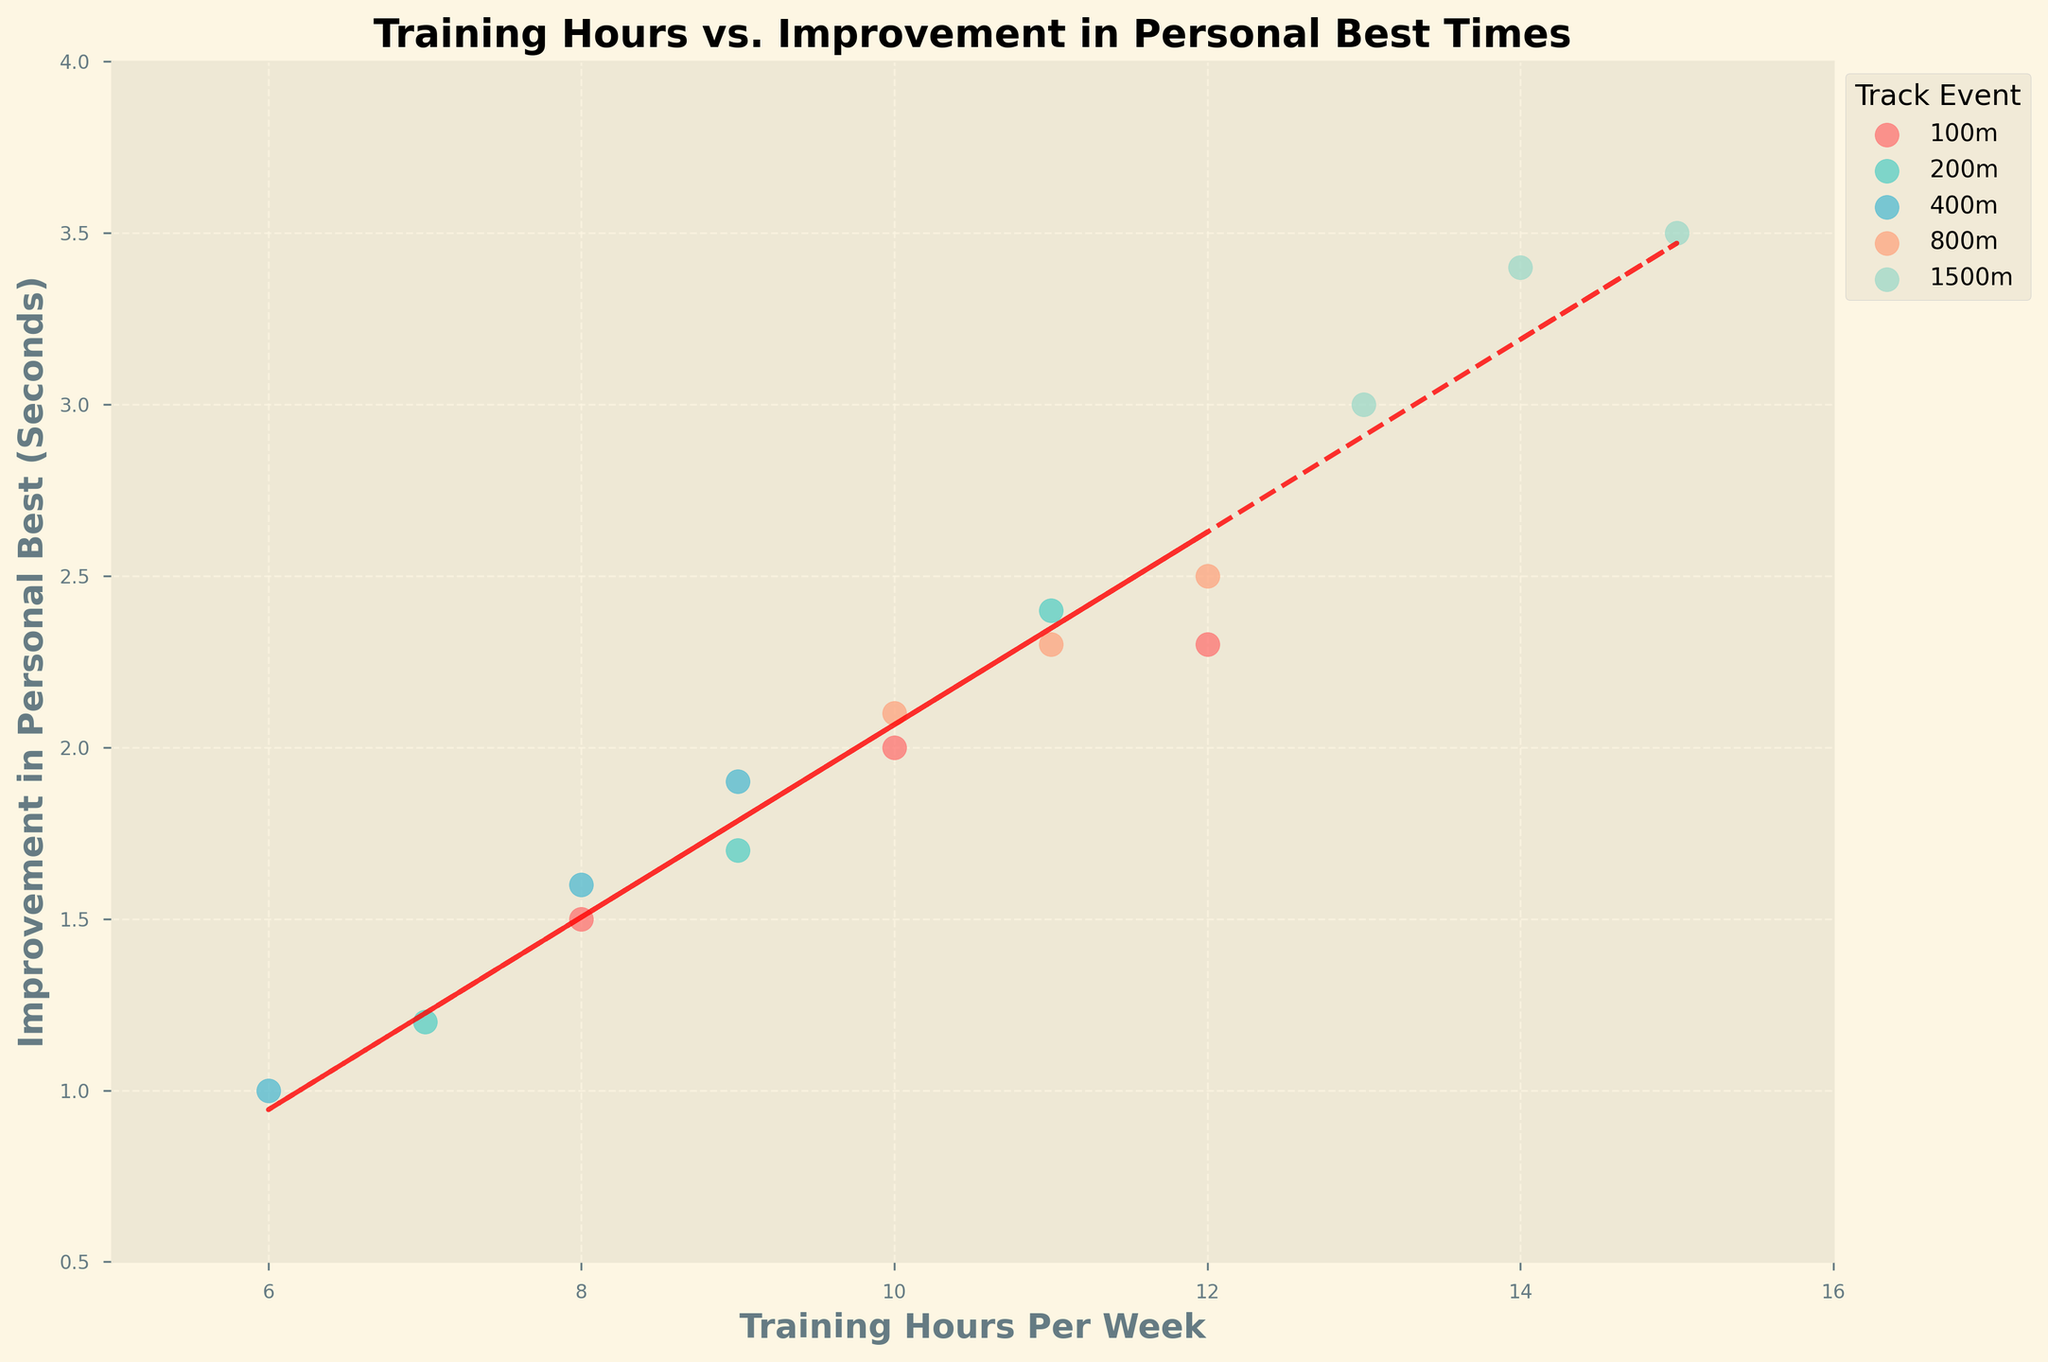What is the title of the plot? The title is usually displayed at the top of the plot and summarizes the subject of the chart. In this case, the title is "Training Hours vs. Improvement in Personal Best Times."
Answer: Training Hours vs. Improvement in Personal Best Times How many unique track events are represented in the plot? To find the number of unique track events, look at the legend and count the different track events specified. The legend shows the colors and the associated track events.
Answer: 5 What is the trend line's general direction? The trend line shows the general relationship between Training Hours Per Week and Improvement in Personal Best Times. It appears to be sloping upwards, indicating that as training hours increase, the improvement in personal best times also tends to increase.
Answer: Upwards Which track event has the color represented by '#4ECDC4'? Look at the legend, where each track event is matched with a specific color. The color '#4ECDC4' corresponds to the 200m event.
Answer: 200m What is the range of training hours per week shown in the plot? The range can be identified by looking at the x-axis, which shows the training hours per week. It starts at 5 and ends at 16.
Answer: 5 to 16 Which track event athletes have the highest improvement in personal best times? Find the highest point(s) on the y-axis and look at the legend to see which track event these points are associated with. The highest improvements are in the 1500m event.
Answer: 1500m Compare the average improvement in personal best times between the 100m and 200m events. Which event shows a greater average improvement? Sum the improvement values for each event, then divide by the number of data points for each event. 100m: (1.5 + 2.0 + 2.3) / 3 = 1.93. 200m: (1.2 + 1.7 + 2.4) / 3 = 1.77.
Answer: 100m Is there any track event where the trend does not seem to follow the general pattern of the trend line? Compare each event's scatter points with the trend line. The event where points deviate the most from the trend line is analyzed to see if it fits the general upward trend.
Answer: No, all follow Which athlete trains the most hours per week, and what is their corresponding improvement in personal best times? Identify the point furthest to the right on the x-axis and look at the y-axis value for this point. The athlete is Jordan Davis with 15 hours per week and an improvement of 3.5 seconds.
Answer: Jordan Davis, 3.5 What range of improvement in personal best times corresponds to athletes who train between 10 and 12 hours per week? Look at the range of y-values for data points between 10 and 12 on the x-axis. The improvements in personal best times range from 2.0 to 2.5 seconds.
Answer: 2.0 to 2.5 seconds 